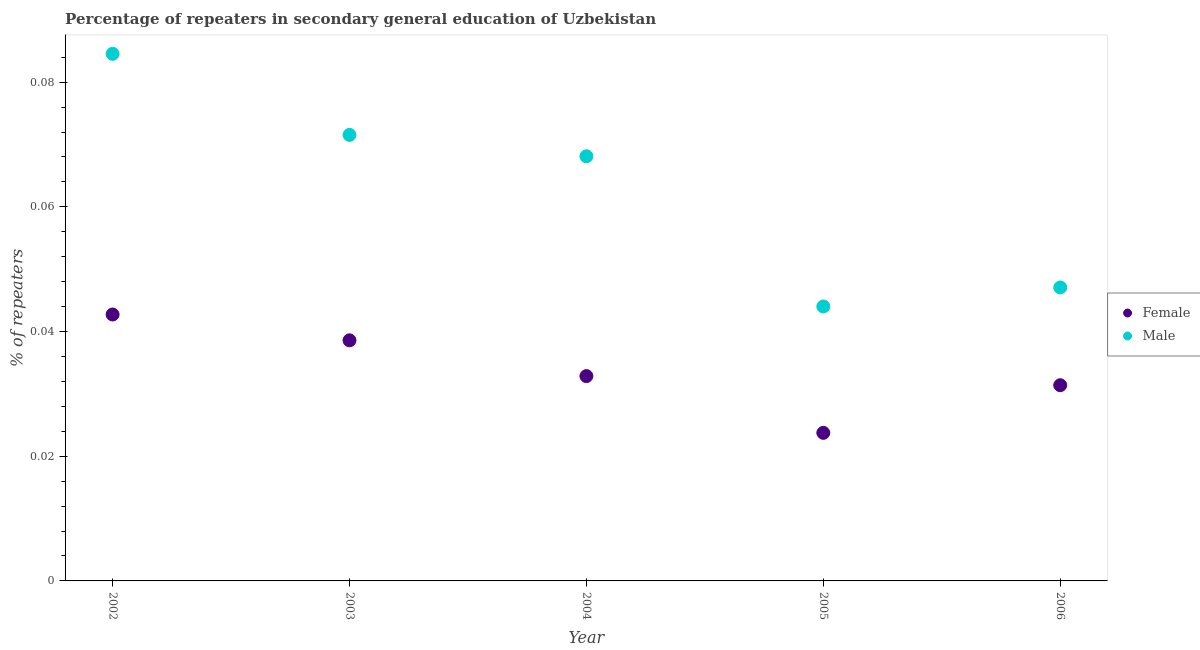How many different coloured dotlines are there?
Provide a short and direct response. 2. What is the percentage of male repeaters in 2005?
Make the answer very short. 0.04. Across all years, what is the maximum percentage of male repeaters?
Give a very brief answer. 0.08. Across all years, what is the minimum percentage of male repeaters?
Provide a short and direct response. 0.04. In which year was the percentage of male repeaters maximum?
Make the answer very short. 2002. In which year was the percentage of male repeaters minimum?
Offer a very short reply. 2005. What is the total percentage of female repeaters in the graph?
Offer a very short reply. 0.17. What is the difference between the percentage of female repeaters in 2002 and that in 2006?
Make the answer very short. 0.01. What is the difference between the percentage of male repeaters in 2003 and the percentage of female repeaters in 2002?
Provide a short and direct response. 0.03. What is the average percentage of male repeaters per year?
Provide a short and direct response. 0.06. In the year 2002, what is the difference between the percentage of female repeaters and percentage of male repeaters?
Your response must be concise. -0.04. In how many years, is the percentage of male repeaters greater than 0.068 %?
Provide a succinct answer. 3. What is the ratio of the percentage of female repeaters in 2005 to that in 2006?
Provide a short and direct response. 0.76. Is the percentage of male repeaters in 2002 less than that in 2003?
Your response must be concise. No. Is the difference between the percentage of male repeaters in 2003 and 2004 greater than the difference between the percentage of female repeaters in 2003 and 2004?
Offer a terse response. No. What is the difference between the highest and the second highest percentage of female repeaters?
Offer a very short reply. 0. What is the difference between the highest and the lowest percentage of female repeaters?
Give a very brief answer. 0.02. Is the percentage of female repeaters strictly less than the percentage of male repeaters over the years?
Your response must be concise. Yes. Are the values on the major ticks of Y-axis written in scientific E-notation?
Make the answer very short. No. Where does the legend appear in the graph?
Offer a very short reply. Center right. What is the title of the graph?
Give a very brief answer. Percentage of repeaters in secondary general education of Uzbekistan. Does "Primary income" appear as one of the legend labels in the graph?
Ensure brevity in your answer.  No. What is the label or title of the X-axis?
Ensure brevity in your answer.  Year. What is the label or title of the Y-axis?
Your response must be concise. % of repeaters. What is the % of repeaters in Female in 2002?
Provide a succinct answer. 0.04. What is the % of repeaters of Male in 2002?
Your answer should be very brief. 0.08. What is the % of repeaters of Female in 2003?
Offer a very short reply. 0.04. What is the % of repeaters in Male in 2003?
Provide a short and direct response. 0.07. What is the % of repeaters in Female in 2004?
Your response must be concise. 0.03. What is the % of repeaters in Male in 2004?
Provide a succinct answer. 0.07. What is the % of repeaters of Female in 2005?
Your answer should be compact. 0.02. What is the % of repeaters of Male in 2005?
Offer a terse response. 0.04. What is the % of repeaters of Female in 2006?
Ensure brevity in your answer.  0.03. What is the % of repeaters in Male in 2006?
Your answer should be compact. 0.05. Across all years, what is the maximum % of repeaters of Female?
Ensure brevity in your answer.  0.04. Across all years, what is the maximum % of repeaters of Male?
Your answer should be compact. 0.08. Across all years, what is the minimum % of repeaters in Female?
Your answer should be compact. 0.02. Across all years, what is the minimum % of repeaters in Male?
Keep it short and to the point. 0.04. What is the total % of repeaters of Female in the graph?
Provide a succinct answer. 0.17. What is the total % of repeaters in Male in the graph?
Provide a succinct answer. 0.32. What is the difference between the % of repeaters of Female in 2002 and that in 2003?
Your answer should be compact. 0. What is the difference between the % of repeaters of Male in 2002 and that in 2003?
Offer a terse response. 0.01. What is the difference between the % of repeaters in Female in 2002 and that in 2004?
Your answer should be compact. 0.01. What is the difference between the % of repeaters in Male in 2002 and that in 2004?
Provide a succinct answer. 0.02. What is the difference between the % of repeaters of Female in 2002 and that in 2005?
Give a very brief answer. 0.02. What is the difference between the % of repeaters in Male in 2002 and that in 2005?
Offer a terse response. 0.04. What is the difference between the % of repeaters of Female in 2002 and that in 2006?
Your response must be concise. 0.01. What is the difference between the % of repeaters in Male in 2002 and that in 2006?
Give a very brief answer. 0.04. What is the difference between the % of repeaters of Female in 2003 and that in 2004?
Your answer should be very brief. 0.01. What is the difference between the % of repeaters in Male in 2003 and that in 2004?
Provide a short and direct response. 0. What is the difference between the % of repeaters of Female in 2003 and that in 2005?
Make the answer very short. 0.01. What is the difference between the % of repeaters of Male in 2003 and that in 2005?
Your answer should be compact. 0.03. What is the difference between the % of repeaters of Female in 2003 and that in 2006?
Provide a short and direct response. 0.01. What is the difference between the % of repeaters of Male in 2003 and that in 2006?
Ensure brevity in your answer.  0.02. What is the difference between the % of repeaters of Female in 2004 and that in 2005?
Give a very brief answer. 0.01. What is the difference between the % of repeaters in Male in 2004 and that in 2005?
Offer a very short reply. 0.02. What is the difference between the % of repeaters of Female in 2004 and that in 2006?
Offer a terse response. 0. What is the difference between the % of repeaters of Male in 2004 and that in 2006?
Your answer should be very brief. 0.02. What is the difference between the % of repeaters in Female in 2005 and that in 2006?
Your answer should be very brief. -0.01. What is the difference between the % of repeaters of Male in 2005 and that in 2006?
Provide a succinct answer. -0. What is the difference between the % of repeaters of Female in 2002 and the % of repeaters of Male in 2003?
Provide a succinct answer. -0.03. What is the difference between the % of repeaters in Female in 2002 and the % of repeaters in Male in 2004?
Your response must be concise. -0.03. What is the difference between the % of repeaters in Female in 2002 and the % of repeaters in Male in 2005?
Give a very brief answer. -0. What is the difference between the % of repeaters of Female in 2002 and the % of repeaters of Male in 2006?
Provide a succinct answer. -0. What is the difference between the % of repeaters of Female in 2003 and the % of repeaters of Male in 2004?
Offer a very short reply. -0.03. What is the difference between the % of repeaters of Female in 2003 and the % of repeaters of Male in 2005?
Your answer should be very brief. -0.01. What is the difference between the % of repeaters of Female in 2003 and the % of repeaters of Male in 2006?
Give a very brief answer. -0.01. What is the difference between the % of repeaters of Female in 2004 and the % of repeaters of Male in 2005?
Offer a terse response. -0.01. What is the difference between the % of repeaters of Female in 2004 and the % of repeaters of Male in 2006?
Your answer should be very brief. -0.01. What is the difference between the % of repeaters in Female in 2005 and the % of repeaters in Male in 2006?
Make the answer very short. -0.02. What is the average % of repeaters of Female per year?
Provide a short and direct response. 0.03. What is the average % of repeaters of Male per year?
Ensure brevity in your answer.  0.06. In the year 2002, what is the difference between the % of repeaters in Female and % of repeaters in Male?
Provide a succinct answer. -0.04. In the year 2003, what is the difference between the % of repeaters in Female and % of repeaters in Male?
Provide a short and direct response. -0.03. In the year 2004, what is the difference between the % of repeaters in Female and % of repeaters in Male?
Your response must be concise. -0.04. In the year 2005, what is the difference between the % of repeaters of Female and % of repeaters of Male?
Provide a short and direct response. -0.02. In the year 2006, what is the difference between the % of repeaters in Female and % of repeaters in Male?
Keep it short and to the point. -0.02. What is the ratio of the % of repeaters in Female in 2002 to that in 2003?
Offer a very short reply. 1.11. What is the ratio of the % of repeaters in Male in 2002 to that in 2003?
Your response must be concise. 1.18. What is the ratio of the % of repeaters in Female in 2002 to that in 2004?
Your answer should be very brief. 1.3. What is the ratio of the % of repeaters in Male in 2002 to that in 2004?
Offer a very short reply. 1.24. What is the ratio of the % of repeaters in Female in 2002 to that in 2005?
Keep it short and to the point. 1.8. What is the ratio of the % of repeaters of Male in 2002 to that in 2005?
Offer a very short reply. 1.92. What is the ratio of the % of repeaters in Female in 2002 to that in 2006?
Your answer should be compact. 1.36. What is the ratio of the % of repeaters in Male in 2002 to that in 2006?
Your answer should be compact. 1.8. What is the ratio of the % of repeaters in Female in 2003 to that in 2004?
Provide a short and direct response. 1.17. What is the ratio of the % of repeaters in Male in 2003 to that in 2004?
Offer a very short reply. 1.05. What is the ratio of the % of repeaters in Female in 2003 to that in 2005?
Your response must be concise. 1.62. What is the ratio of the % of repeaters in Male in 2003 to that in 2005?
Give a very brief answer. 1.63. What is the ratio of the % of repeaters in Female in 2003 to that in 2006?
Your answer should be compact. 1.23. What is the ratio of the % of repeaters of Male in 2003 to that in 2006?
Give a very brief answer. 1.52. What is the ratio of the % of repeaters in Female in 2004 to that in 2005?
Offer a terse response. 1.38. What is the ratio of the % of repeaters of Male in 2004 to that in 2005?
Offer a very short reply. 1.55. What is the ratio of the % of repeaters of Female in 2004 to that in 2006?
Ensure brevity in your answer.  1.05. What is the ratio of the % of repeaters of Male in 2004 to that in 2006?
Your answer should be compact. 1.45. What is the ratio of the % of repeaters of Female in 2005 to that in 2006?
Provide a short and direct response. 0.76. What is the ratio of the % of repeaters of Male in 2005 to that in 2006?
Your answer should be very brief. 0.94. What is the difference between the highest and the second highest % of repeaters of Female?
Your answer should be compact. 0. What is the difference between the highest and the second highest % of repeaters in Male?
Provide a succinct answer. 0.01. What is the difference between the highest and the lowest % of repeaters in Female?
Offer a very short reply. 0.02. What is the difference between the highest and the lowest % of repeaters in Male?
Provide a succinct answer. 0.04. 